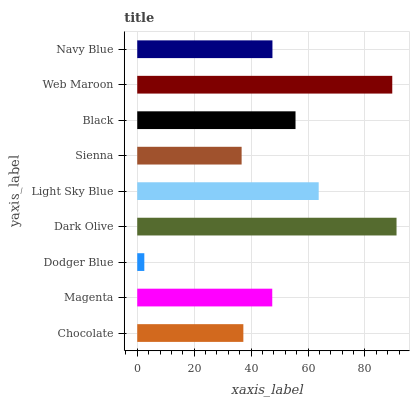Is Dodger Blue the minimum?
Answer yes or no. Yes. Is Dark Olive the maximum?
Answer yes or no. Yes. Is Magenta the minimum?
Answer yes or no. No. Is Magenta the maximum?
Answer yes or no. No. Is Magenta greater than Chocolate?
Answer yes or no. Yes. Is Chocolate less than Magenta?
Answer yes or no. Yes. Is Chocolate greater than Magenta?
Answer yes or no. No. Is Magenta less than Chocolate?
Answer yes or no. No. Is Navy Blue the high median?
Answer yes or no. Yes. Is Navy Blue the low median?
Answer yes or no. Yes. Is Light Sky Blue the high median?
Answer yes or no. No. Is Dodger Blue the low median?
Answer yes or no. No. 